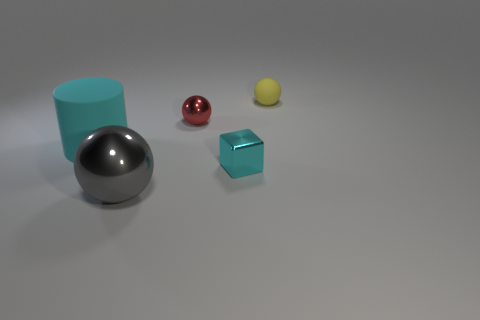What number of other large shiny spheres are the same color as the large ball?
Offer a terse response. 0. How many small things are in front of the yellow sphere and behind the cyan cylinder?
Keep it short and to the point. 1. What shape is the rubber object that is the same size as the gray sphere?
Offer a terse response. Cylinder. How big is the yellow ball?
Make the answer very short. Small. There is a small ball left of the tiny yellow matte object that is behind the tiny metallic object that is in front of the red metallic sphere; what is it made of?
Offer a very short reply. Metal. The other sphere that is the same material as the large gray sphere is what color?
Offer a very short reply. Red. What number of large gray shiny spheres are to the left of the cyan thing that is in front of the rubber object on the left side of the small yellow matte thing?
Your answer should be compact. 1. What material is the tiny thing that is the same color as the large rubber cylinder?
Ensure brevity in your answer.  Metal. Is there any other thing that is the same shape as the big gray thing?
Your answer should be very brief. Yes. How many objects are either metal objects behind the big metallic sphere or tiny rubber things?
Keep it short and to the point. 3. 